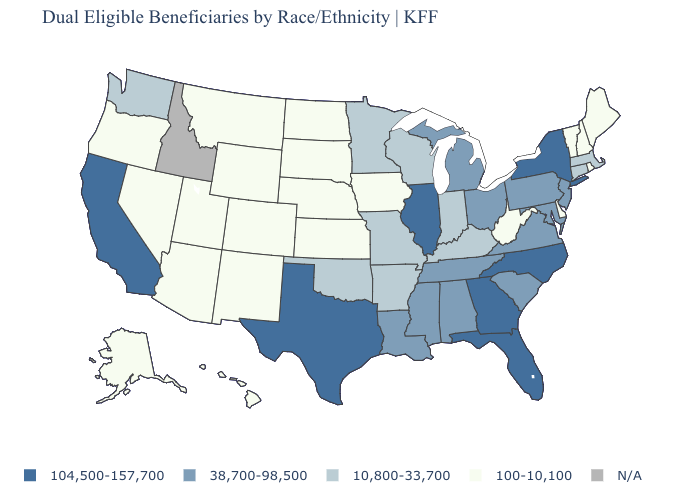Among the states that border Arkansas , which have the highest value?
Concise answer only. Texas. Name the states that have a value in the range 38,700-98,500?
Keep it brief. Alabama, Louisiana, Maryland, Michigan, Mississippi, New Jersey, Ohio, Pennsylvania, South Carolina, Tennessee, Virginia. What is the value of Colorado?
Concise answer only. 100-10,100. Name the states that have a value in the range 10,800-33,700?
Keep it brief. Arkansas, Connecticut, Indiana, Kentucky, Massachusetts, Minnesota, Missouri, Oklahoma, Washington, Wisconsin. What is the highest value in the South ?
Answer briefly. 104,500-157,700. Name the states that have a value in the range 100-10,100?
Answer briefly. Alaska, Arizona, Colorado, Delaware, Hawaii, Iowa, Kansas, Maine, Montana, Nebraska, Nevada, New Hampshire, New Mexico, North Dakota, Oregon, Rhode Island, South Dakota, Utah, Vermont, West Virginia, Wyoming. How many symbols are there in the legend?
Write a very short answer. 5. Name the states that have a value in the range 38,700-98,500?
Keep it brief. Alabama, Louisiana, Maryland, Michigan, Mississippi, New Jersey, Ohio, Pennsylvania, South Carolina, Tennessee, Virginia. Name the states that have a value in the range 100-10,100?
Keep it brief. Alaska, Arizona, Colorado, Delaware, Hawaii, Iowa, Kansas, Maine, Montana, Nebraska, Nevada, New Hampshire, New Mexico, North Dakota, Oregon, Rhode Island, South Dakota, Utah, Vermont, West Virginia, Wyoming. Name the states that have a value in the range 38,700-98,500?
Concise answer only. Alabama, Louisiana, Maryland, Michigan, Mississippi, New Jersey, Ohio, Pennsylvania, South Carolina, Tennessee, Virginia. Name the states that have a value in the range 10,800-33,700?
Give a very brief answer. Arkansas, Connecticut, Indiana, Kentucky, Massachusetts, Minnesota, Missouri, Oklahoma, Washington, Wisconsin. What is the value of Vermont?
Concise answer only. 100-10,100. Which states have the lowest value in the South?
Quick response, please. Delaware, West Virginia. 